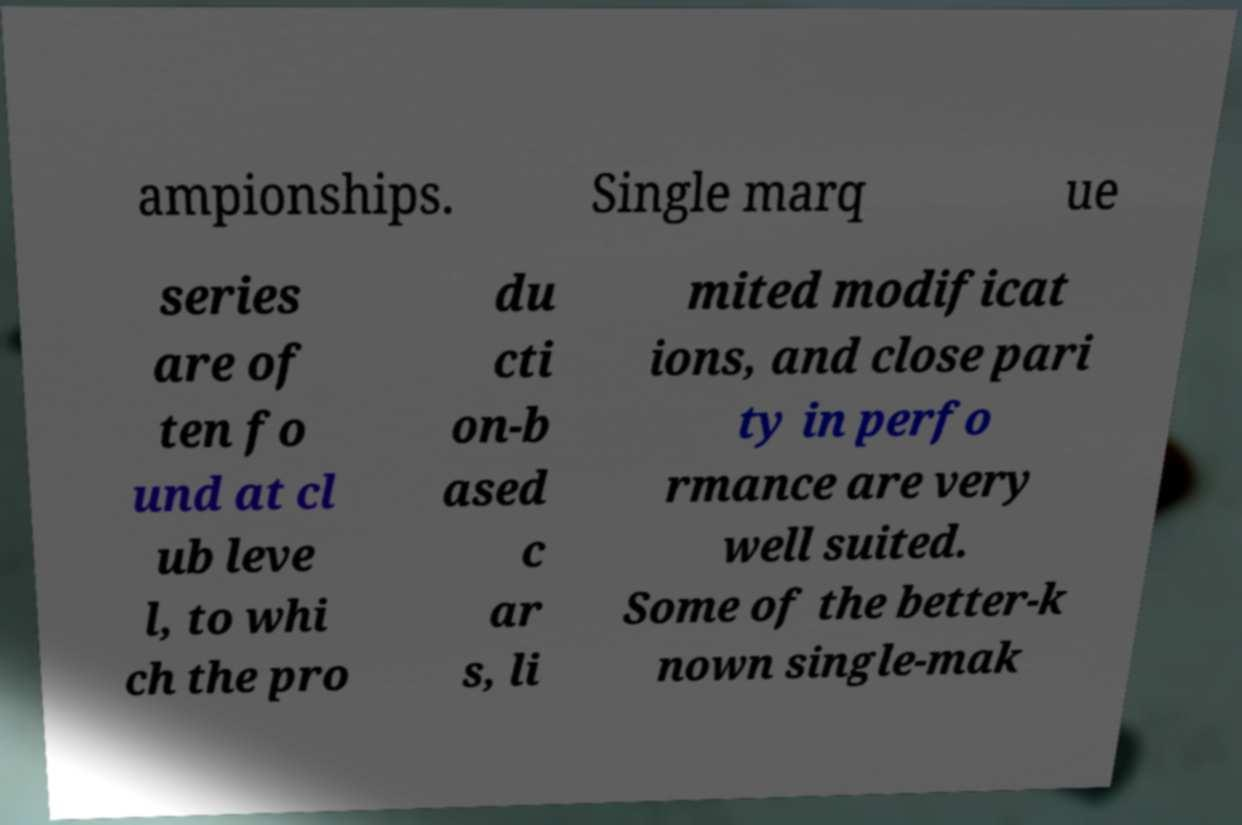What messages or text are displayed in this image? I need them in a readable, typed format. ampionships. Single marq ue series are of ten fo und at cl ub leve l, to whi ch the pro du cti on-b ased c ar s, li mited modificat ions, and close pari ty in perfo rmance are very well suited. Some of the better-k nown single-mak 